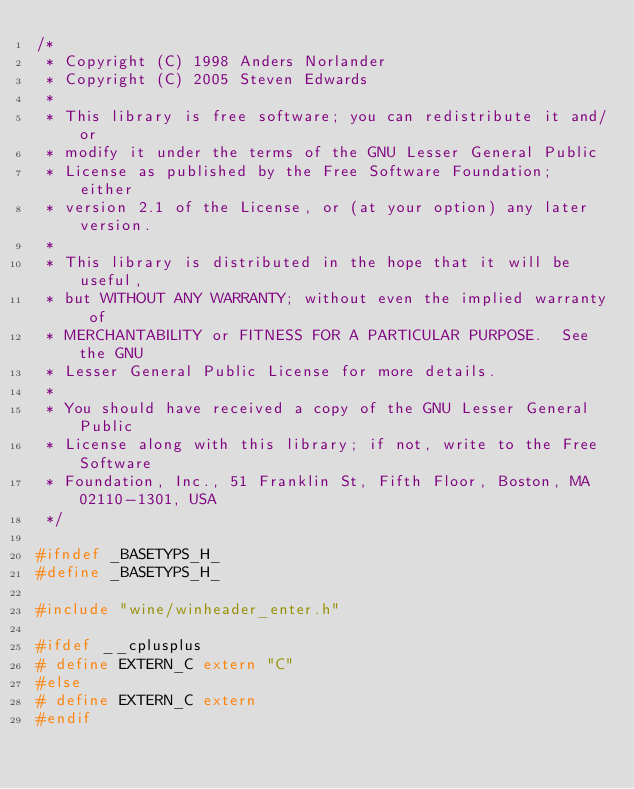Convert code to text. <code><loc_0><loc_0><loc_500><loc_500><_C_>/*
 * Copyright (C) 1998 Anders Norlander
 * Copyright (C) 2005 Steven Edwards
 *
 * This library is free software; you can redistribute it and/or
 * modify it under the terms of the GNU Lesser General Public
 * License as published by the Free Software Foundation; either
 * version 2.1 of the License, or (at your option) any later version.
 *
 * This library is distributed in the hope that it will be useful,
 * but WITHOUT ANY WARRANTY; without even the implied warranty of
 * MERCHANTABILITY or FITNESS FOR A PARTICULAR PURPOSE.  See the GNU
 * Lesser General Public License for more details.
 *
 * You should have received a copy of the GNU Lesser General Public
 * License along with this library; if not, write to the Free Software
 * Foundation, Inc., 51 Franklin St, Fifth Floor, Boston, MA 02110-1301, USA
 */

#ifndef _BASETYPS_H_
#define _BASETYPS_H_

#include "wine/winheader_enter.h"

#ifdef __cplusplus
# define EXTERN_C extern "C"
#else
# define EXTERN_C extern
#endif
</code> 